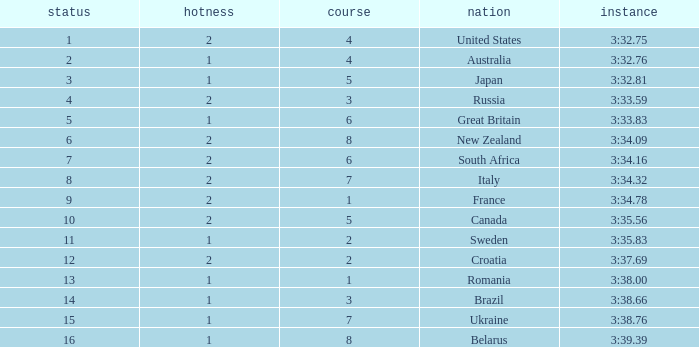Could you inform me about the time with a heat level of 1 and a lane number of 2? 3:35.83. 